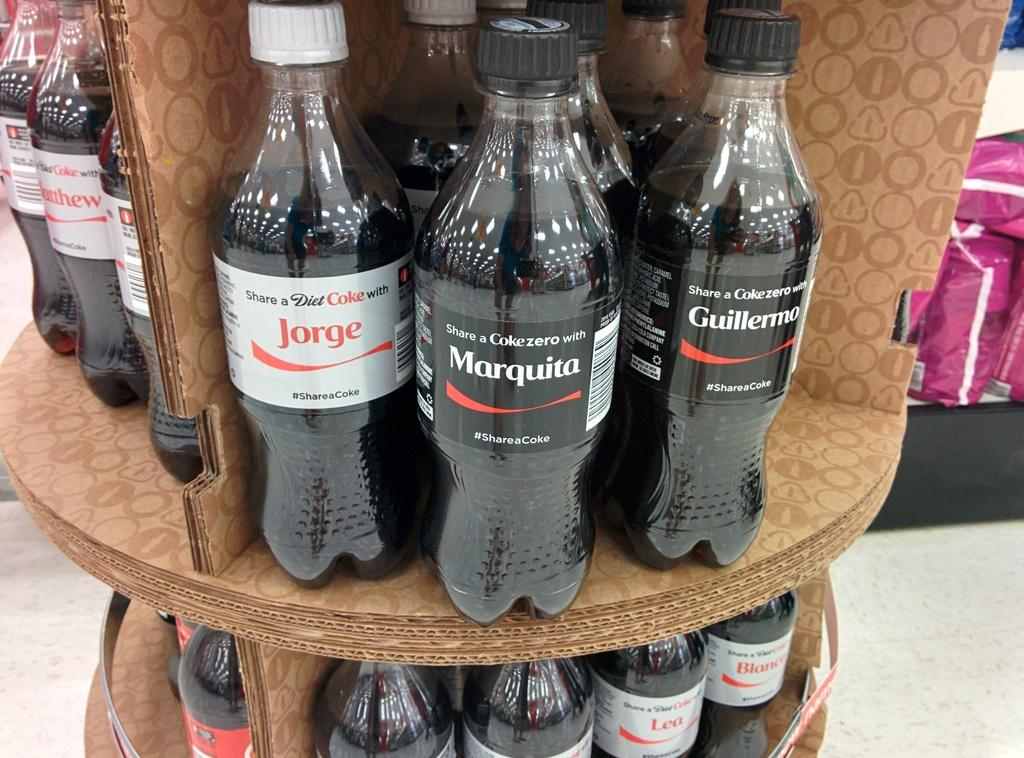What can be seen on the table in the image? There are bottles with different labels on the table. Can you describe the products visible at the back of the image? Unfortunately, the provided facts do not mention any products visible at the back of the image. How many sheep are present in the image? There are no sheep present in the image. What is the shape of the bed in the image? There is no bed present in the image. 